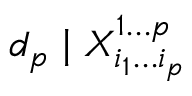<formula> <loc_0><loc_0><loc_500><loc_500>d _ { p } | X _ { i _ { 1 } \dots c i _ { p } } ^ { 1 \dots c p }</formula> 